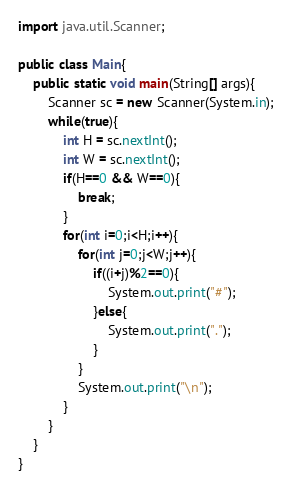<code> <loc_0><loc_0><loc_500><loc_500><_Java_>import java.util.Scanner;

public class Main{
	public static void main(String[] args){
		Scanner sc = new Scanner(System.in);
		while(true){
			int H = sc.nextInt();
			int W = sc.nextInt();
			if(H==0 && W==0){
				break;
			}
			for(int i=0;i<H;i++){
				for(int j=0;j<W;j++){
					if((i+j)%2==0){
						System.out.print("#");
					}else{
						System.out.print(".");
					}
				}
				System.out.print("\n");
			}
		}
	}
}
</code> 